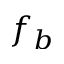<formula> <loc_0><loc_0><loc_500><loc_500>f _ { b }</formula> 